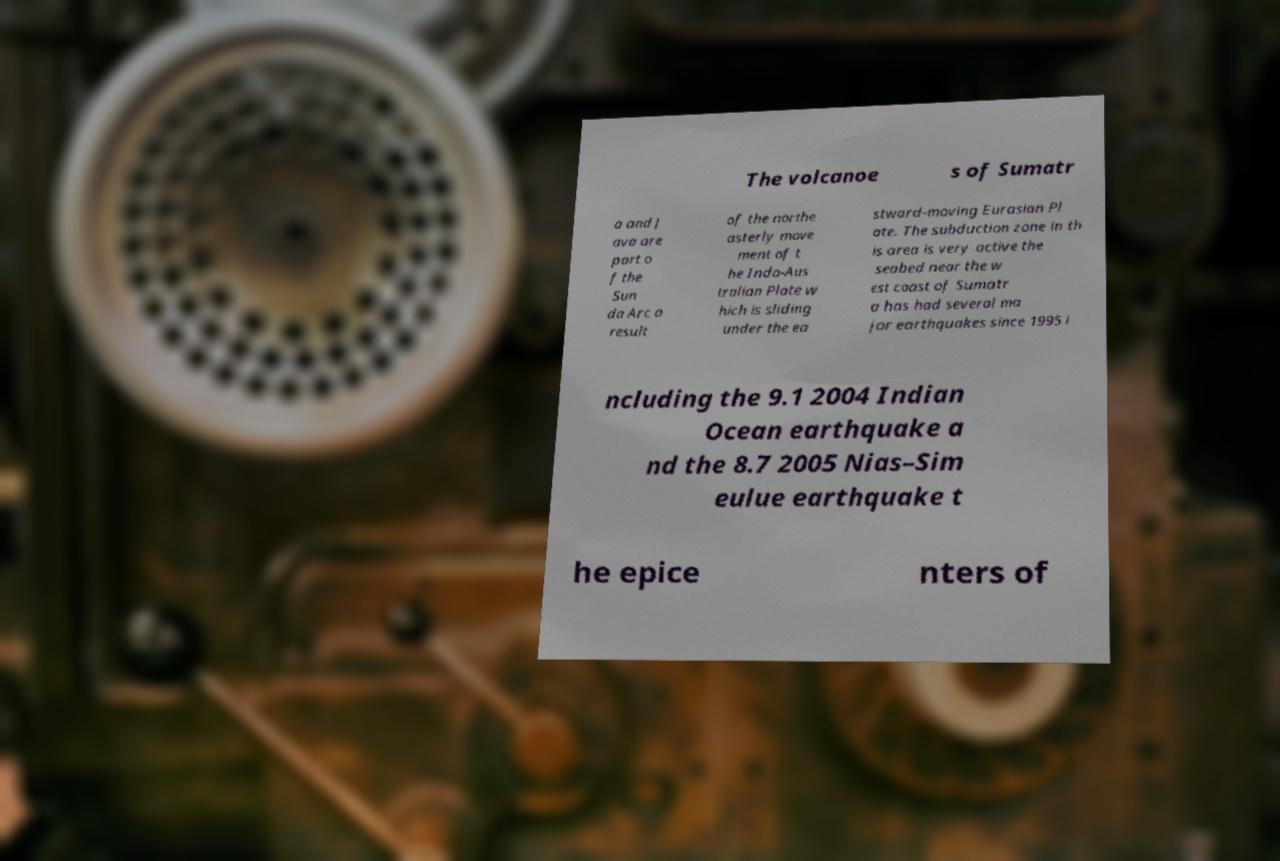Please identify and transcribe the text found in this image. The volcanoe s of Sumatr a and J ava are part o f the Sun da Arc a result of the northe asterly move ment of t he Indo-Aus tralian Plate w hich is sliding under the ea stward-moving Eurasian Pl ate. The subduction zone in th is area is very active the seabed near the w est coast of Sumatr a has had several ma jor earthquakes since 1995 i ncluding the 9.1 2004 Indian Ocean earthquake a nd the 8.7 2005 Nias–Sim eulue earthquake t he epice nters of 